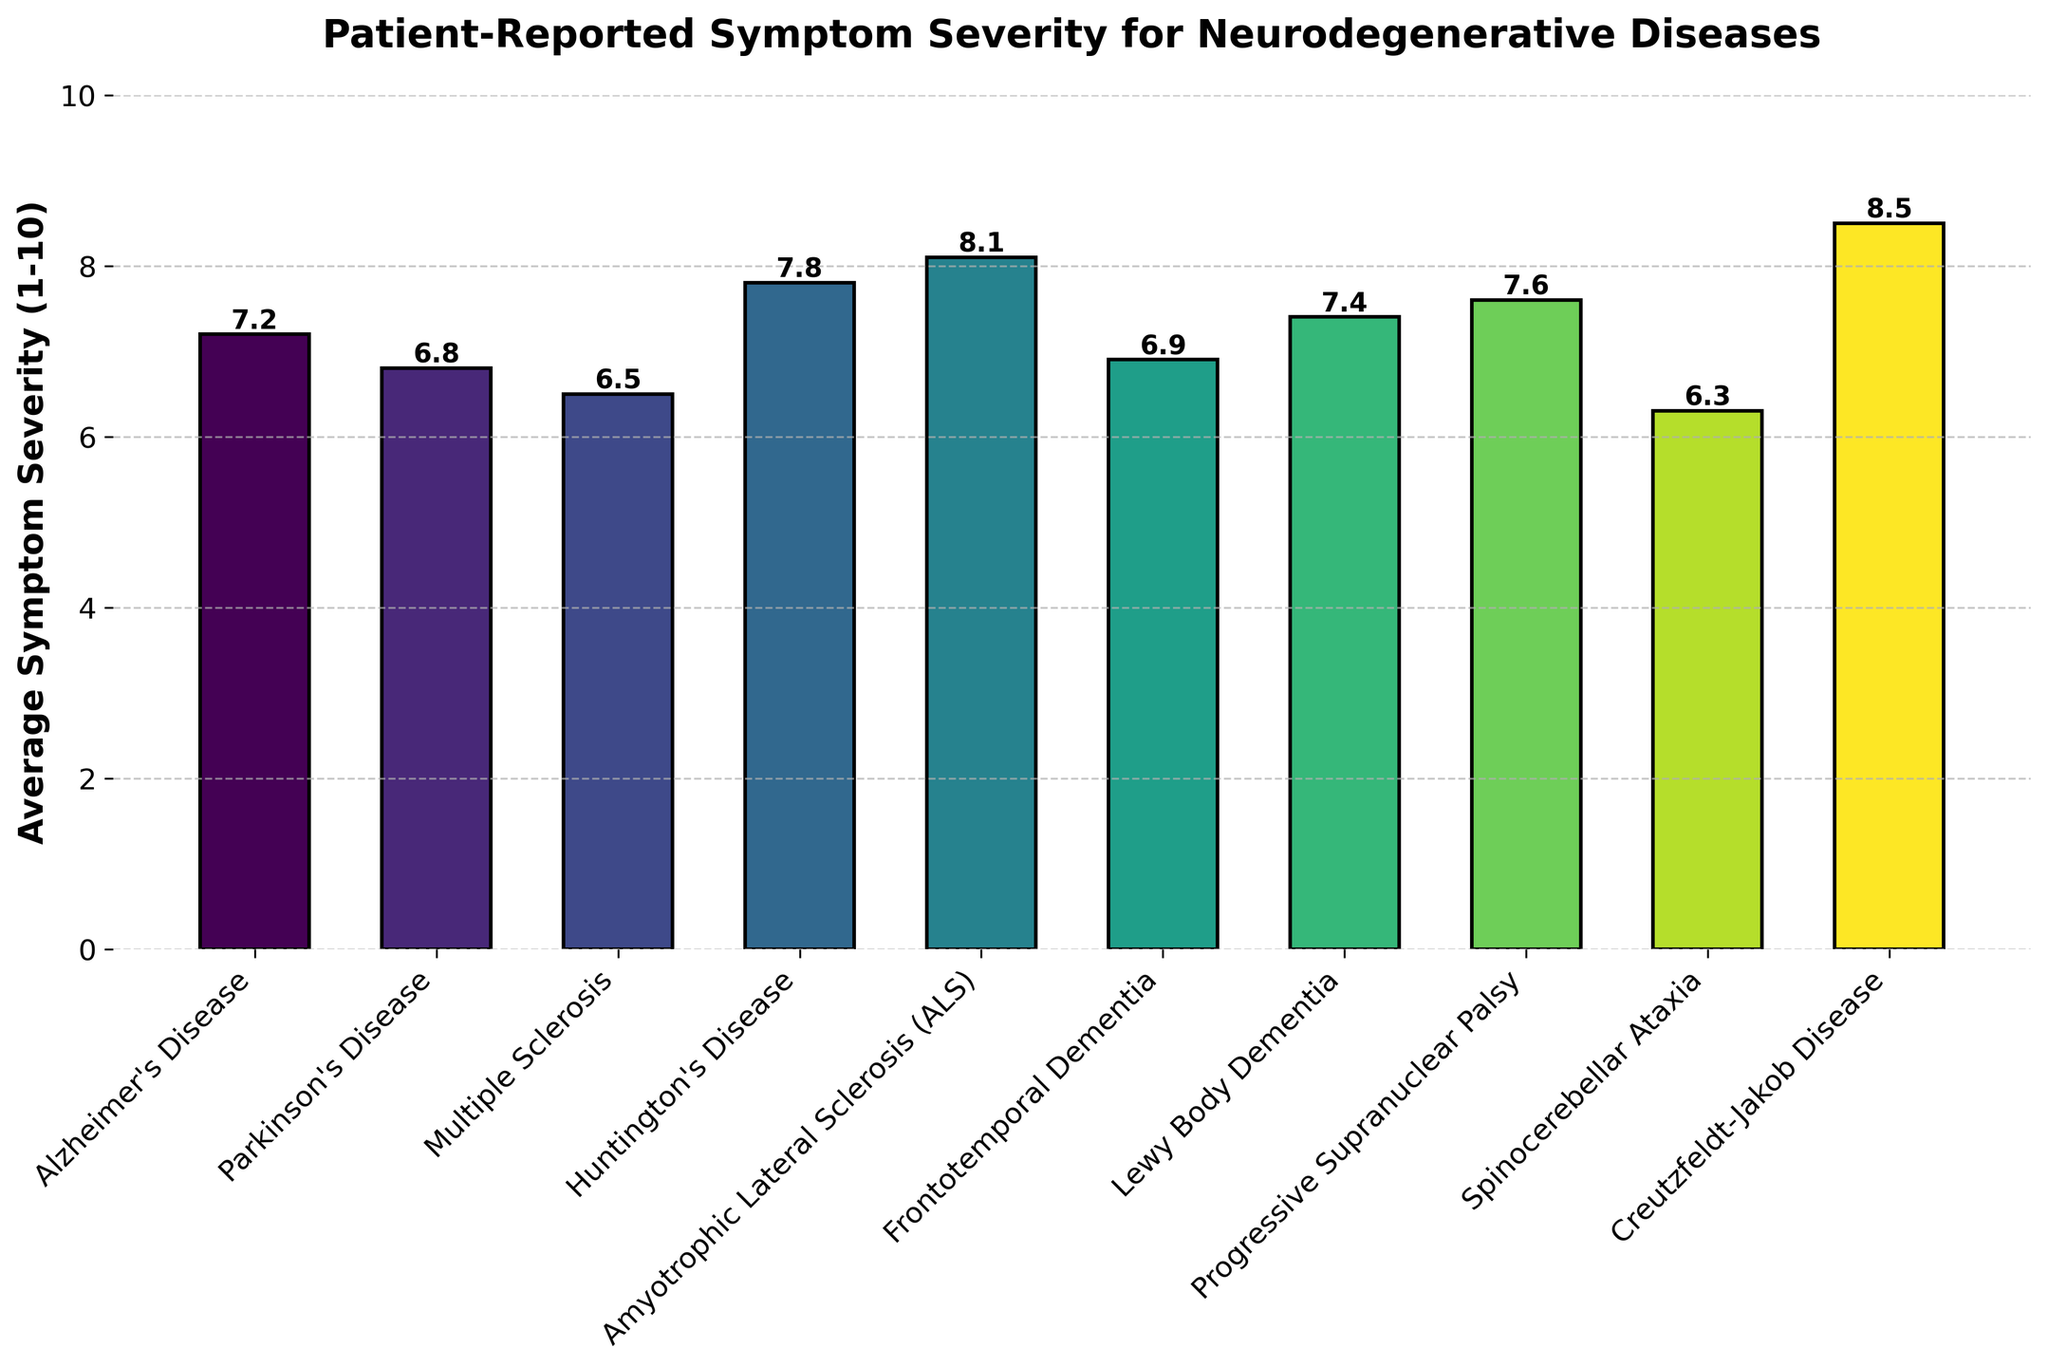What disease has the highest reported symptom severity? The highest point on the bar chart indicates the disease with the highest symptom severity. Creutzfeldt-Jakob Disease has the highest bar with a severity of 8.5.
Answer: Creutzfeldt-Jakob Disease What disease has the lowest reported symptom severity? The lowest point on the bar chart indicates the disease with the lowest symptom severity. Spinocerebellar Ataxia has the lowest bar with a severity of 6.3.
Answer: Spinocerebellar Ataxia What is the difference in symptom severity between Huntington's Disease and Parkinson's Disease? To find the difference, subtract the severity of Parkinson's Disease (6.8) from the severity of Huntington's Disease (7.8). 7.8 - 6.8 = 1.0.
Answer: 1.0 What is the average symptom severity of Alzheimer's Disease, Lewy Body Dementia, and Frontotemporal Dementia? First, sum their severities: 7.2 (Alzheimer's) + 7.4 (Lewy Body Dementia) + 6.9 (Frontotemporal Dementia). The sum is 21.5. Then, divide by the number of diseases: 21.5 / 3 = 7.17.
Answer: 7.17 Which disease has a symptom severity closest to 7.0? Look for the bars that have severity values around 7.0. Alzheimer's Disease (7.2) and Frontotemporal Dementia (6.9) are closest, with Frontotemporal Dementia being closest at 6.9.
Answer: Frontotemporal Dementia How many diseases have a symptom severity greater than 7.0? Count the bars with values greater than 7.0: Alzheimer's Disease (7.2), Huntington's Disease (7.8), Amyotrophic Lateral Sclerosis (8.1), Lewy Body Dementia (7.4), Progressive Supranuclear Palsy (7.6), and Creutzfeldt-Jakob Disease (8.5). There are 6 diseases.
Answer: 6 Are there more diseases with symptom severity above or below the median severity? First, list all severities (in ascending order): 6.3, 6.5, 6.8, 6.9, 7.2, 7.4, 7.6, 7.8, 8.1, 8.5. The median is the average of the 5th and 6th values: (7.2 + 7.4) / 2 = 7.3. Below 7.3: 6.3, 6.5, 6.8, 6.9, 7.2 (5 diseases). Above 7.3: 7.4, 7.6, 7.8, 8.1, 8.5 (5 diseases). There are equal numbers above and below.
Answer: Equal What is the total sum of symptom severities for all diseases? Sum all the severity values: 7.2 + 6.8 + 6.5 + 7.8 + 8.1 + 6.9 + 7.4 + 7.6 + 6.3 + 8.5 = 73.1.
Answer: 73.1 